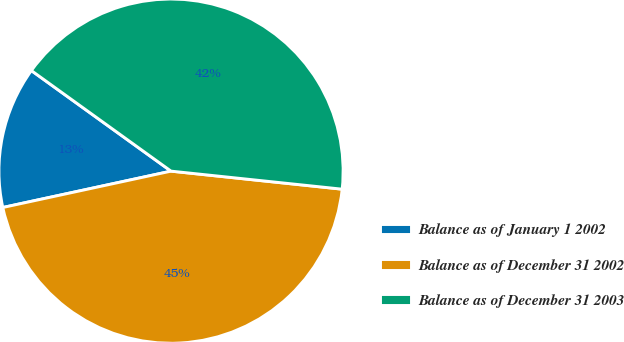Convert chart to OTSL. <chart><loc_0><loc_0><loc_500><loc_500><pie_chart><fcel>Balance as of January 1 2002<fcel>Balance as of December 31 2002<fcel>Balance as of December 31 2003<nl><fcel>13.32%<fcel>44.94%<fcel>41.74%<nl></chart> 